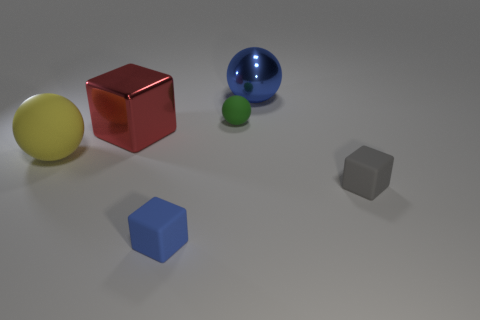What number of small gray things are there?
Your response must be concise. 1. There is a small object behind the yellow thing; how many metal balls are to the left of it?
Ensure brevity in your answer.  0. Do the big metallic ball and the matte block to the left of the gray rubber thing have the same color?
Offer a very short reply. Yes. How many blue matte things have the same shape as the red object?
Provide a succinct answer. 1. What is the material of the blue object that is behind the red cube?
Provide a short and direct response. Metal. There is a rubber object in front of the tiny gray block; does it have the same shape as the big red thing?
Provide a succinct answer. Yes. Are there any red metal objects that have the same size as the blue sphere?
Provide a succinct answer. Yes. There is a yellow matte thing; is its shape the same as the tiny object that is on the right side of the large blue thing?
Provide a succinct answer. No. Is the number of gray things behind the gray block less than the number of green objects?
Offer a very short reply. Yes. Is the tiny green thing the same shape as the big yellow rubber thing?
Offer a very short reply. Yes. 